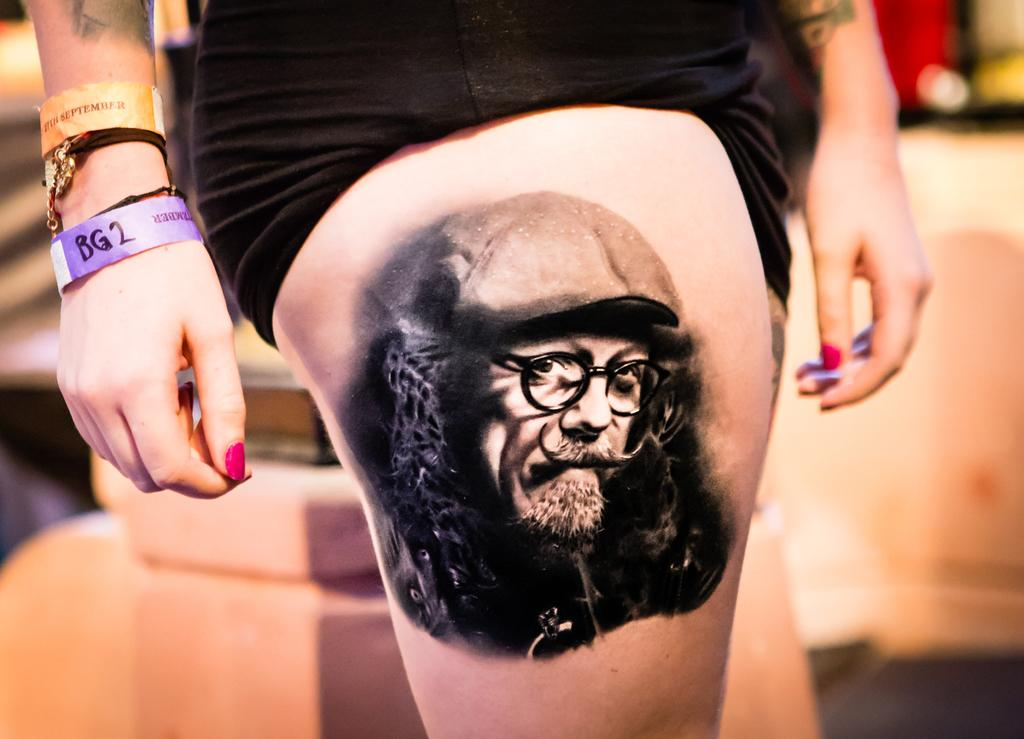What type of body art can be seen on the person's leg in the image? There is a tattoo of a person's face on the person's leg in the image. What color is the dress the person is wearing? The person is wearing a black dress. What type of accessory is the person wearing on their arms? The person is wearing bands on their arms. How would you describe the background of the image? The background of the image is blurred. How many screws are visible on the person's leg in the image? There are no screws visible on the person's leg in the image. What type of pin can be seen holding the person's dress together in the image? There is no pin visible holding the person's dress together in the image. 